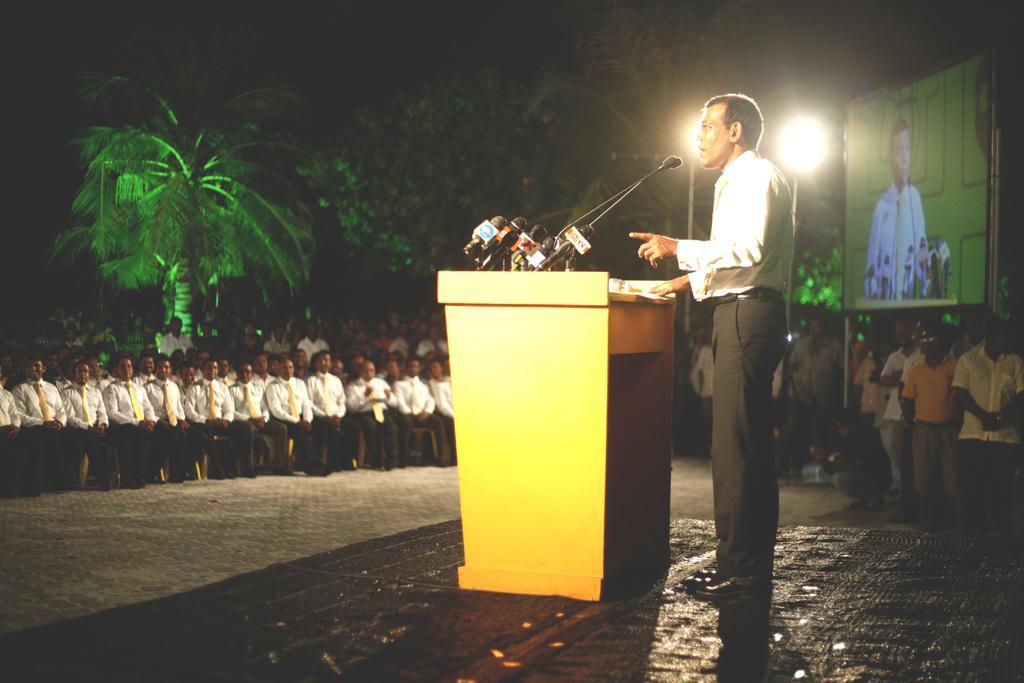Can you describe this image briefly? This is an image clicked in the dark. On the right side there is a man standing in front of the podium facing towards the left side and speaking on the microphone. On the left side, I can see many people are sitting on the chairs. On the right side many people are standing and everyone is looking at this man. At the back of these people there is a screen on which I can see this person. Beside there are few light poles. In the background there are many trees in the dark. 